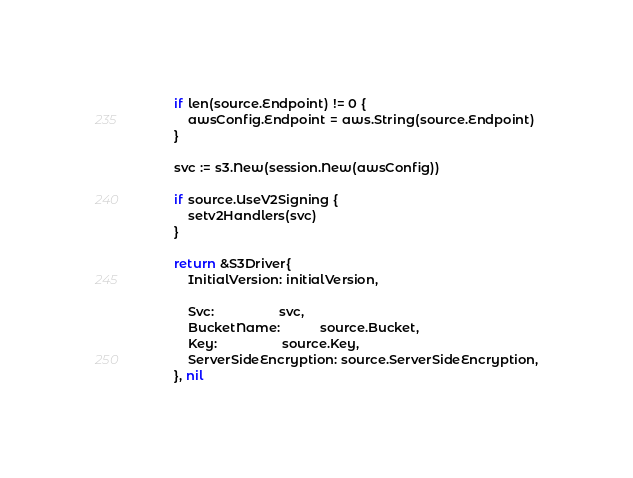<code> <loc_0><loc_0><loc_500><loc_500><_Go_>		if len(source.Endpoint) != 0 {
			awsConfig.Endpoint = aws.String(source.Endpoint)
		}

		svc := s3.New(session.New(awsConfig))

		if source.UseV2Signing {
			setv2Handlers(svc)
		}

		return &S3Driver{
			InitialVersion: initialVersion,

			Svc:                  svc,
			BucketName:           source.Bucket,
			Key:                  source.Key,
			ServerSideEncryption: source.ServerSideEncryption,
		}, nil
</code> 